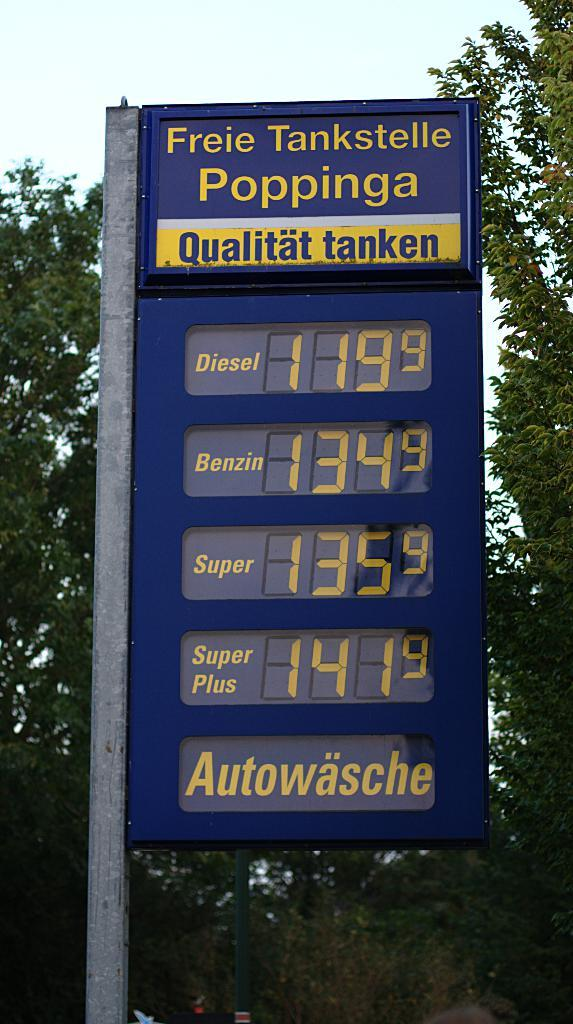What type of price board is in the image? There is a blue color digital price board in the image. What can be seen in the background of the image? Trees are visible in the image. What is visible at the top of the image? The sky is visible at the top of the image. Can you describe the kitten playing with the price board in the image? There is no kitten present in the image, and therefore no such activity can be observed. 